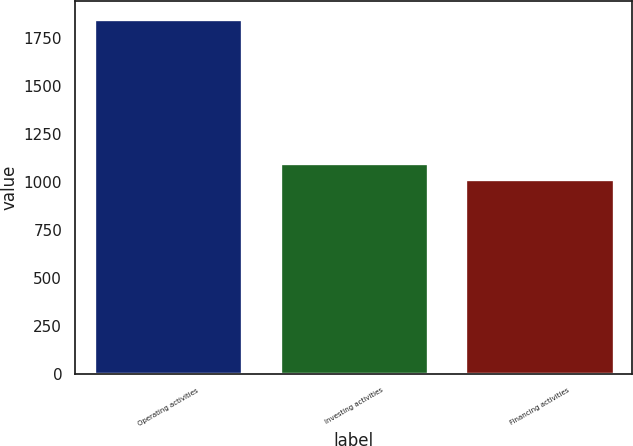Convert chart. <chart><loc_0><loc_0><loc_500><loc_500><bar_chart><fcel>Operating activities<fcel>Investing activities<fcel>Financing activities<nl><fcel>1850.2<fcel>1099.24<fcel>1015.8<nl></chart> 